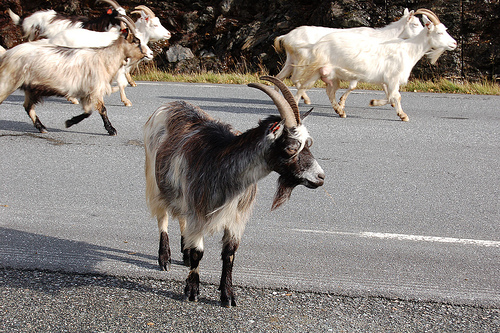<image>
Is the goat to the right of the goat? No. The goat is not to the right of the goat. The horizontal positioning shows a different relationship. Is there a animals next to the road? No. The animals is not positioned next to the road. They are located in different areas of the scene. 